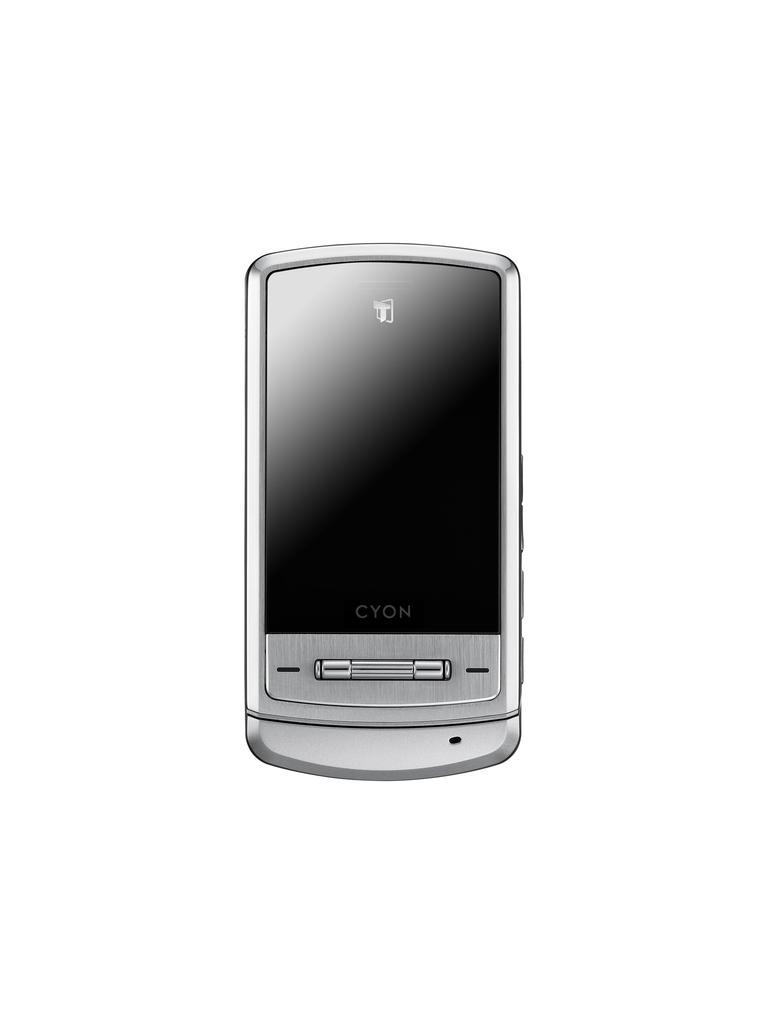Describe this image in one or two sentences. In this image the background is white in color. In the middle of the image there is a mobile phone which is silver in color. 